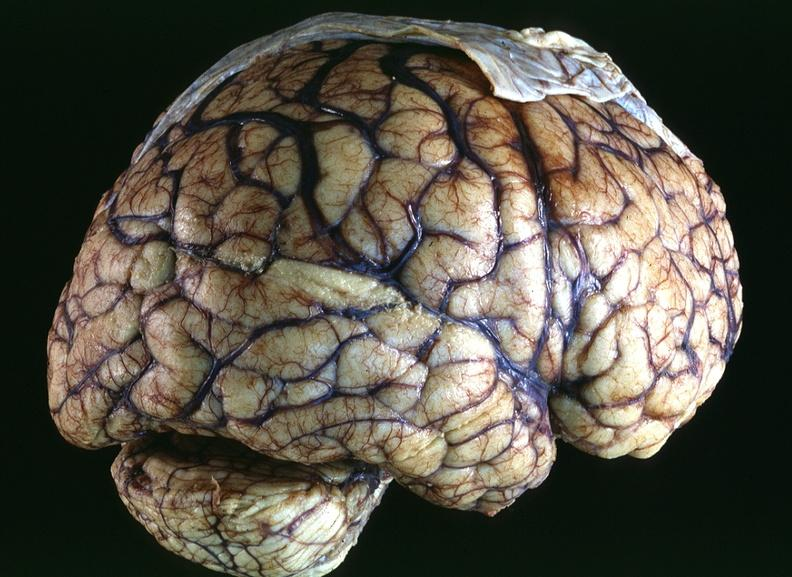does this image show toxoplasmosis, brain?
Answer the question using a single word or phrase. Yes 